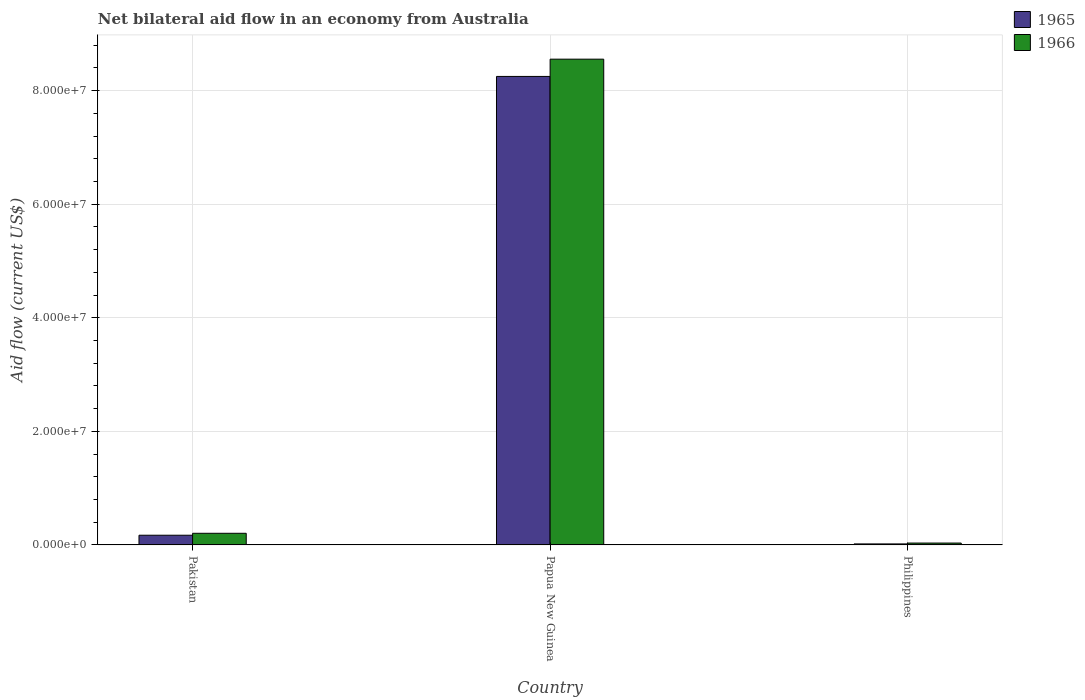How many groups of bars are there?
Offer a terse response. 3. What is the label of the 2nd group of bars from the left?
Keep it short and to the point. Papua New Guinea. What is the net bilateral aid flow in 1966 in Papua New Guinea?
Offer a terse response. 8.56e+07. Across all countries, what is the maximum net bilateral aid flow in 1965?
Provide a succinct answer. 8.25e+07. In which country was the net bilateral aid flow in 1965 maximum?
Offer a very short reply. Papua New Guinea. What is the total net bilateral aid flow in 1965 in the graph?
Give a very brief answer. 8.44e+07. What is the difference between the net bilateral aid flow in 1965 in Pakistan and that in Philippines?
Ensure brevity in your answer.  1.53e+06. What is the difference between the net bilateral aid flow in 1965 in Pakistan and the net bilateral aid flow in 1966 in Papua New Guinea?
Offer a very short reply. -8.38e+07. What is the average net bilateral aid flow in 1965 per country?
Provide a succinct answer. 2.81e+07. What is the difference between the net bilateral aid flow of/in 1966 and net bilateral aid flow of/in 1965 in Papua New Guinea?
Your answer should be compact. 3.04e+06. In how many countries, is the net bilateral aid flow in 1966 greater than 8000000 US$?
Offer a terse response. 1. What is the ratio of the net bilateral aid flow in 1966 in Papua New Guinea to that in Philippines?
Give a very brief answer. 259.24. What is the difference between the highest and the second highest net bilateral aid flow in 1966?
Make the answer very short. 8.52e+07. What is the difference between the highest and the lowest net bilateral aid flow in 1966?
Keep it short and to the point. 8.52e+07. In how many countries, is the net bilateral aid flow in 1966 greater than the average net bilateral aid flow in 1966 taken over all countries?
Ensure brevity in your answer.  1. Is the sum of the net bilateral aid flow in 1965 in Papua New Guinea and Philippines greater than the maximum net bilateral aid flow in 1966 across all countries?
Offer a very short reply. No. What does the 2nd bar from the left in Philippines represents?
Give a very brief answer. 1966. What does the 2nd bar from the right in Papua New Guinea represents?
Make the answer very short. 1965. Are all the bars in the graph horizontal?
Your response must be concise. No. How many countries are there in the graph?
Give a very brief answer. 3. What is the difference between two consecutive major ticks on the Y-axis?
Provide a short and direct response. 2.00e+07. Are the values on the major ticks of Y-axis written in scientific E-notation?
Offer a terse response. Yes. Does the graph contain grids?
Your response must be concise. Yes. How are the legend labels stacked?
Make the answer very short. Vertical. What is the title of the graph?
Provide a succinct answer. Net bilateral aid flow in an economy from Australia. Does "1960" appear as one of the legend labels in the graph?
Your answer should be compact. No. What is the label or title of the Y-axis?
Provide a short and direct response. Aid flow (current US$). What is the Aid flow (current US$) of 1965 in Pakistan?
Provide a short and direct response. 1.71e+06. What is the Aid flow (current US$) in 1966 in Pakistan?
Offer a very short reply. 2.05e+06. What is the Aid flow (current US$) of 1965 in Papua New Guinea?
Give a very brief answer. 8.25e+07. What is the Aid flow (current US$) of 1966 in Papua New Guinea?
Provide a short and direct response. 8.56e+07. What is the Aid flow (current US$) in 1965 in Philippines?
Your answer should be compact. 1.80e+05. Across all countries, what is the maximum Aid flow (current US$) in 1965?
Ensure brevity in your answer.  8.25e+07. Across all countries, what is the maximum Aid flow (current US$) in 1966?
Offer a terse response. 8.56e+07. Across all countries, what is the minimum Aid flow (current US$) in 1965?
Make the answer very short. 1.80e+05. What is the total Aid flow (current US$) of 1965 in the graph?
Keep it short and to the point. 8.44e+07. What is the total Aid flow (current US$) in 1966 in the graph?
Make the answer very short. 8.79e+07. What is the difference between the Aid flow (current US$) of 1965 in Pakistan and that in Papua New Guinea?
Offer a very short reply. -8.08e+07. What is the difference between the Aid flow (current US$) in 1966 in Pakistan and that in Papua New Guinea?
Offer a terse response. -8.35e+07. What is the difference between the Aid flow (current US$) of 1965 in Pakistan and that in Philippines?
Provide a succinct answer. 1.53e+06. What is the difference between the Aid flow (current US$) of 1966 in Pakistan and that in Philippines?
Make the answer very short. 1.72e+06. What is the difference between the Aid flow (current US$) of 1965 in Papua New Guinea and that in Philippines?
Offer a terse response. 8.23e+07. What is the difference between the Aid flow (current US$) of 1966 in Papua New Guinea and that in Philippines?
Offer a very short reply. 8.52e+07. What is the difference between the Aid flow (current US$) in 1965 in Pakistan and the Aid flow (current US$) in 1966 in Papua New Guinea?
Your answer should be very brief. -8.38e+07. What is the difference between the Aid flow (current US$) in 1965 in Pakistan and the Aid flow (current US$) in 1966 in Philippines?
Your answer should be very brief. 1.38e+06. What is the difference between the Aid flow (current US$) in 1965 in Papua New Guinea and the Aid flow (current US$) in 1966 in Philippines?
Your answer should be compact. 8.22e+07. What is the average Aid flow (current US$) in 1965 per country?
Keep it short and to the point. 2.81e+07. What is the average Aid flow (current US$) of 1966 per country?
Offer a terse response. 2.93e+07. What is the difference between the Aid flow (current US$) in 1965 and Aid flow (current US$) in 1966 in Papua New Guinea?
Ensure brevity in your answer.  -3.04e+06. What is the difference between the Aid flow (current US$) in 1965 and Aid flow (current US$) in 1966 in Philippines?
Your answer should be compact. -1.50e+05. What is the ratio of the Aid flow (current US$) of 1965 in Pakistan to that in Papua New Guinea?
Your answer should be very brief. 0.02. What is the ratio of the Aid flow (current US$) in 1966 in Pakistan to that in Papua New Guinea?
Your answer should be very brief. 0.02. What is the ratio of the Aid flow (current US$) of 1965 in Pakistan to that in Philippines?
Keep it short and to the point. 9.5. What is the ratio of the Aid flow (current US$) in 1966 in Pakistan to that in Philippines?
Offer a terse response. 6.21. What is the ratio of the Aid flow (current US$) in 1965 in Papua New Guinea to that in Philippines?
Offer a terse response. 458.39. What is the ratio of the Aid flow (current US$) in 1966 in Papua New Guinea to that in Philippines?
Your response must be concise. 259.24. What is the difference between the highest and the second highest Aid flow (current US$) in 1965?
Provide a short and direct response. 8.08e+07. What is the difference between the highest and the second highest Aid flow (current US$) of 1966?
Offer a terse response. 8.35e+07. What is the difference between the highest and the lowest Aid flow (current US$) in 1965?
Keep it short and to the point. 8.23e+07. What is the difference between the highest and the lowest Aid flow (current US$) in 1966?
Your response must be concise. 8.52e+07. 